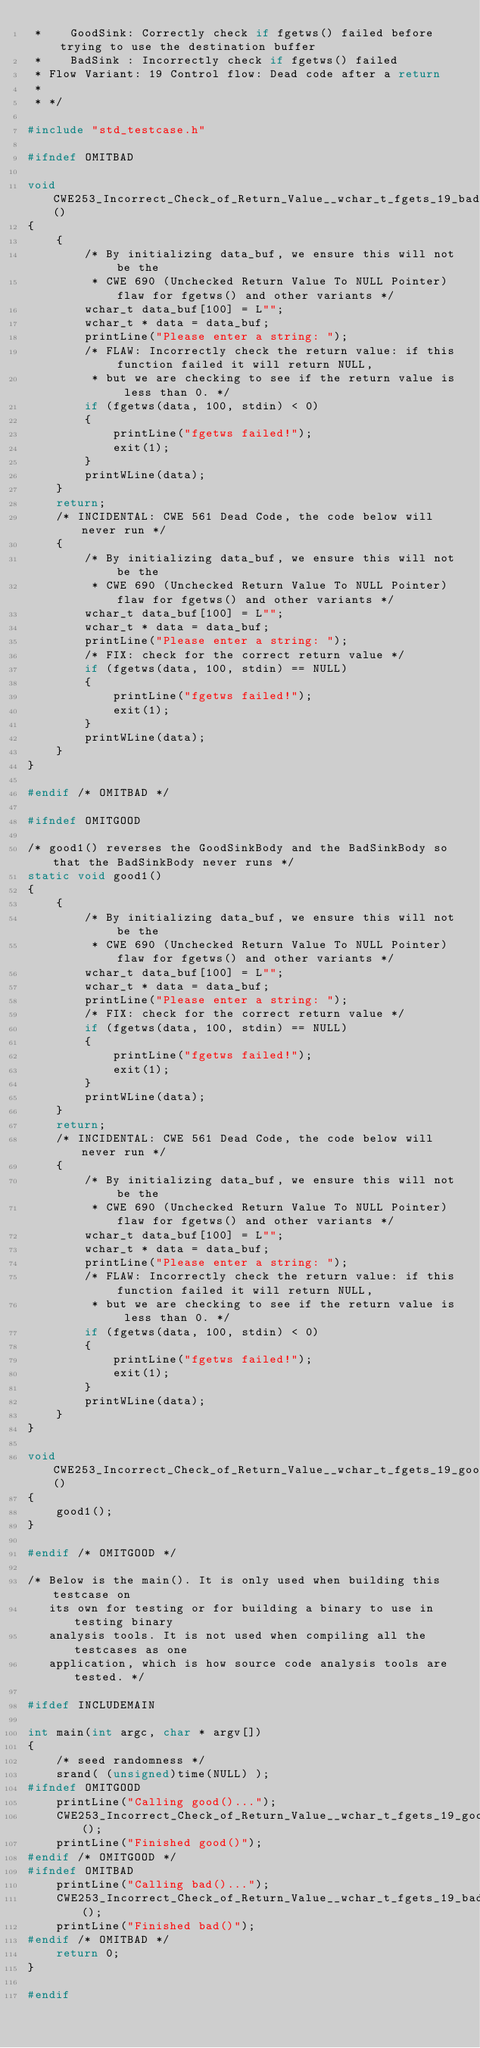Convert code to text. <code><loc_0><loc_0><loc_500><loc_500><_C_> *    GoodSink: Correctly check if fgetws() failed before trying to use the destination buffer
 *    BadSink : Incorrectly check if fgetws() failed
 * Flow Variant: 19 Control flow: Dead code after a return
 *
 * */

#include "std_testcase.h"

#ifndef OMITBAD

void CWE253_Incorrect_Check_of_Return_Value__wchar_t_fgets_19_bad()
{
    {
        /* By initializing data_buf, we ensure this will not be the
         * CWE 690 (Unchecked Return Value To NULL Pointer) flaw for fgetws() and other variants */
        wchar_t data_buf[100] = L"";
        wchar_t * data = data_buf;
        printLine("Please enter a string: ");
        /* FLAW: Incorrectly check the return value: if this function failed it will return NULL,
         * but we are checking to see if the return value is less than 0. */
        if (fgetws(data, 100, stdin) < 0)
        {
            printLine("fgetws failed!");
            exit(1);
        }
        printWLine(data);
    }
    return;
    /* INCIDENTAL: CWE 561 Dead Code, the code below will never run */
    {
        /* By initializing data_buf, we ensure this will not be the
         * CWE 690 (Unchecked Return Value To NULL Pointer) flaw for fgetws() and other variants */
        wchar_t data_buf[100] = L"";
        wchar_t * data = data_buf;
        printLine("Please enter a string: ");
        /* FIX: check for the correct return value */
        if (fgetws(data, 100, stdin) == NULL)
        {
            printLine("fgetws failed!");
            exit(1);
        }
        printWLine(data);
    }
}

#endif /* OMITBAD */

#ifndef OMITGOOD

/* good1() reverses the GoodSinkBody and the BadSinkBody so that the BadSinkBody never runs */
static void good1()
{
    {
        /* By initializing data_buf, we ensure this will not be the
         * CWE 690 (Unchecked Return Value To NULL Pointer) flaw for fgetws() and other variants */
        wchar_t data_buf[100] = L"";
        wchar_t * data = data_buf;
        printLine("Please enter a string: ");
        /* FIX: check for the correct return value */
        if (fgetws(data, 100, stdin) == NULL)
        {
            printLine("fgetws failed!");
            exit(1);
        }
        printWLine(data);
    }
    return;
    /* INCIDENTAL: CWE 561 Dead Code, the code below will never run */
    {
        /* By initializing data_buf, we ensure this will not be the
         * CWE 690 (Unchecked Return Value To NULL Pointer) flaw for fgetws() and other variants */
        wchar_t data_buf[100] = L"";
        wchar_t * data = data_buf;
        printLine("Please enter a string: ");
        /* FLAW: Incorrectly check the return value: if this function failed it will return NULL,
         * but we are checking to see if the return value is less than 0. */
        if (fgetws(data, 100, stdin) < 0)
        {
            printLine("fgetws failed!");
            exit(1);
        }
        printWLine(data);
    }
}

void CWE253_Incorrect_Check_of_Return_Value__wchar_t_fgets_19_good()
{
    good1();
}

#endif /* OMITGOOD */

/* Below is the main(). It is only used when building this testcase on
   its own for testing or for building a binary to use in testing binary
   analysis tools. It is not used when compiling all the testcases as one
   application, which is how source code analysis tools are tested. */

#ifdef INCLUDEMAIN

int main(int argc, char * argv[])
{
    /* seed randomness */
    srand( (unsigned)time(NULL) );
#ifndef OMITGOOD
    printLine("Calling good()...");
    CWE253_Incorrect_Check_of_Return_Value__wchar_t_fgets_19_good();
    printLine("Finished good()");
#endif /* OMITGOOD */
#ifndef OMITBAD
    printLine("Calling bad()...");
    CWE253_Incorrect_Check_of_Return_Value__wchar_t_fgets_19_bad();
    printLine("Finished bad()");
#endif /* OMITBAD */
    return 0;
}

#endif
</code> 